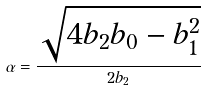Convert formula to latex. <formula><loc_0><loc_0><loc_500><loc_500>\alpha = \frac { \sqrt { 4 b _ { 2 } b _ { 0 } - b _ { 1 } ^ { 2 } } } { 2 b _ { 2 } }</formula> 